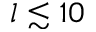<formula> <loc_0><loc_0><loc_500><loc_500>l \lesssim 1 0</formula> 